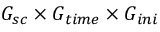Convert formula to latex. <formula><loc_0><loc_0><loc_500><loc_500>G _ { s c } \times G _ { t i m e } \times G _ { i n i }</formula> 